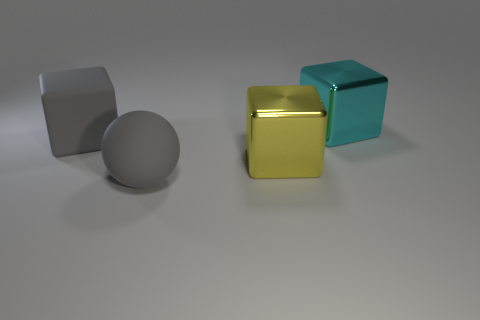Add 1 large matte cubes. How many objects exist? 5 Subtract all cubes. How many objects are left? 1 Add 1 cyan things. How many cyan things exist? 2 Subtract 0 green blocks. How many objects are left? 4 Subtract all gray blocks. Subtract all cyan things. How many objects are left? 2 Add 4 large gray rubber things. How many large gray rubber things are left? 6 